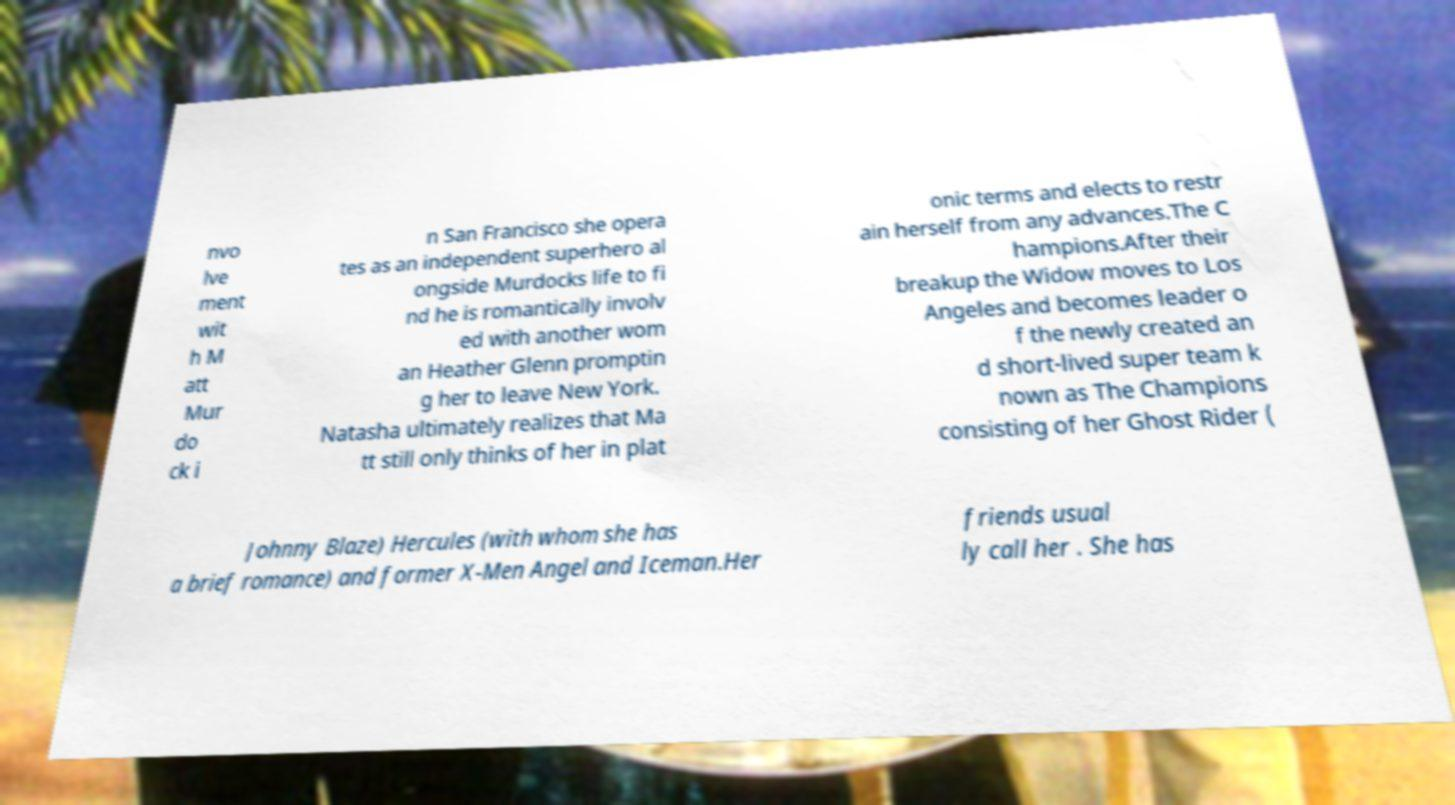Could you assist in decoding the text presented in this image and type it out clearly? nvo lve ment wit h M att Mur do ck i n San Francisco she opera tes as an independent superhero al ongside Murdocks life to fi nd he is romantically involv ed with another wom an Heather Glenn promptin g her to leave New York. Natasha ultimately realizes that Ma tt still only thinks of her in plat onic terms and elects to restr ain herself from any advances.The C hampions.After their breakup the Widow moves to Los Angeles and becomes leader o f the newly created an d short-lived super team k nown as The Champions consisting of her Ghost Rider ( Johnny Blaze) Hercules (with whom she has a brief romance) and former X-Men Angel and Iceman.Her friends usual ly call her . She has 